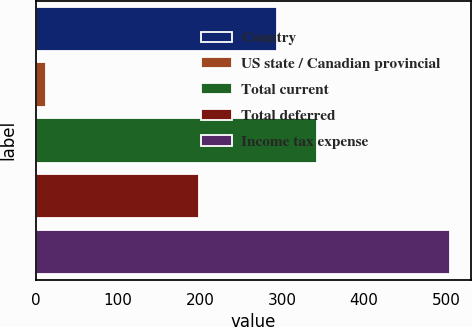Convert chart to OTSL. <chart><loc_0><loc_0><loc_500><loc_500><bar_chart><fcel>Country<fcel>US state / Canadian provincial<fcel>Total current<fcel>Total deferred<fcel>Income tax expense<nl><fcel>294<fcel>12<fcel>343.3<fcel>199<fcel>505<nl></chart> 